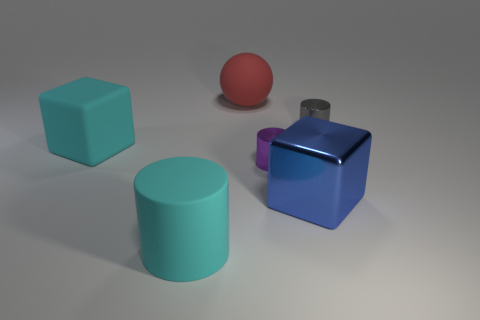Does the large matte cylinder have the same color as the big rubber cube?
Offer a very short reply. Yes. What number of big cyan things have the same shape as the gray thing?
Make the answer very short. 1. What color is the cube that is right of the large cylinder?
Your answer should be compact. Blue. What number of metal objects are cubes or tiny yellow cylinders?
Provide a short and direct response. 1. What shape is the large thing that is the same color as the matte block?
Provide a short and direct response. Cylinder. What number of purple shiny things have the same size as the matte block?
Make the answer very short. 0. There is a rubber thing that is both behind the tiny purple metal object and in front of the red rubber thing; what color is it?
Make the answer very short. Cyan. What number of objects are either blue metal things or cylinders?
Ensure brevity in your answer.  4. How many tiny things are either matte things or cyan rubber cubes?
Keep it short and to the point. 0. Is there any other thing that is the same color as the large matte cylinder?
Provide a succinct answer. Yes. 